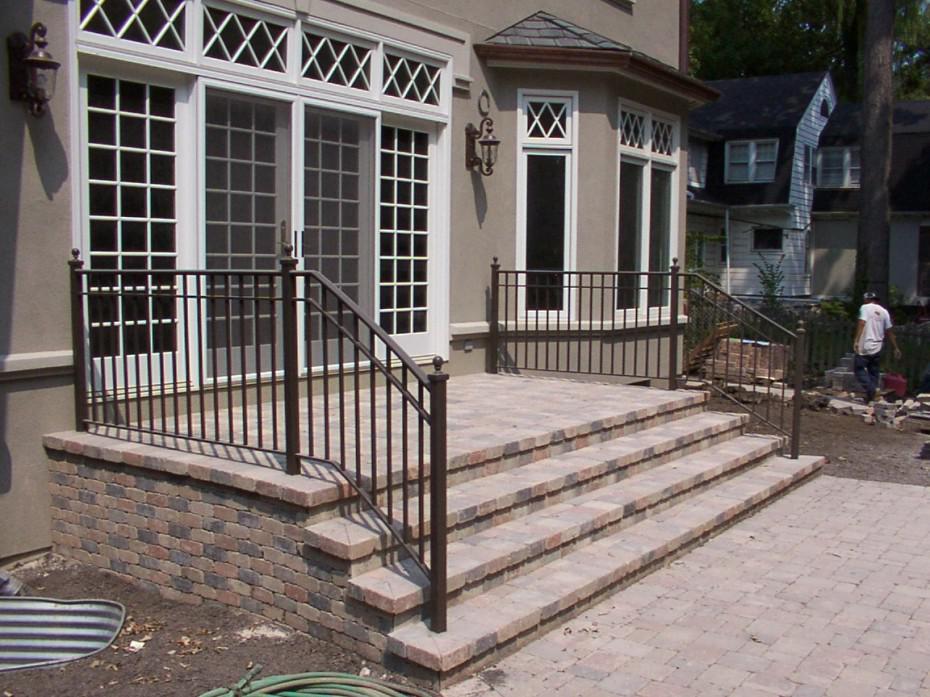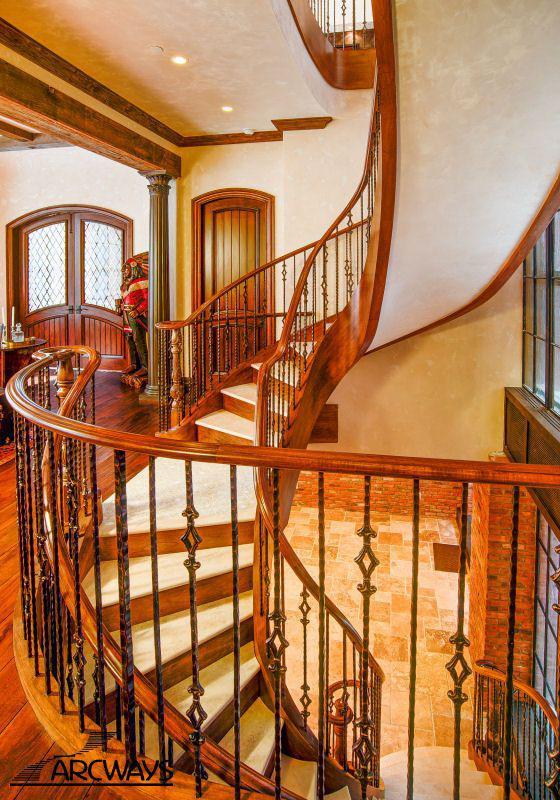The first image is the image on the left, the second image is the image on the right. Analyze the images presented: Is the assertion "The exterior of a house is shown with stairs that have very dark-colored railings." valid? Answer yes or no. Yes. The first image is the image on the left, the second image is the image on the right. Evaluate the accuracy of this statement regarding the images: "One of the images shows an entrance to a home and the other image shows a wooden staircase with metal balusters.". Is it true? Answer yes or no. Yes. 